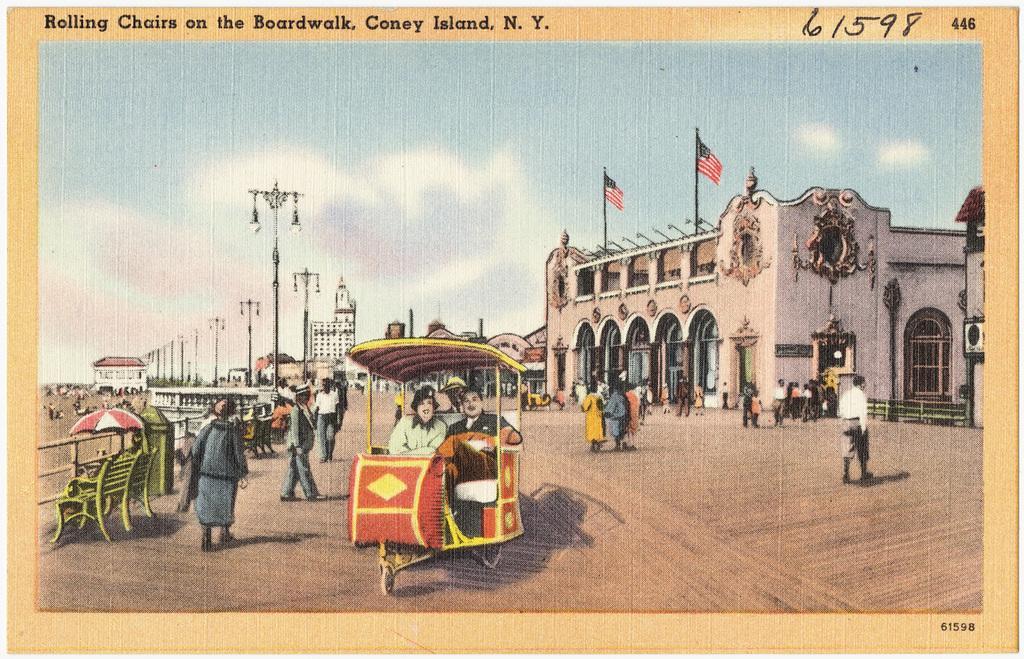Could you give a brief overview of what you see in this image? It is a poster. In this image, we can see a group of people, buildings, poles, lights, benches, umbrella, walls. Here we can see few people are inside the cart. Background there is a sky. At the top of the image, we can see numbers and text. Right side bottom, we can see numbers. 